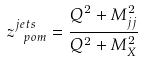<formula> <loc_0><loc_0><loc_500><loc_500>z ^ { j e t s } _ { \ p o m } = \frac { Q ^ { 2 } + M _ { j j } ^ { 2 } } { Q ^ { 2 } + M _ { X } ^ { 2 } }</formula> 